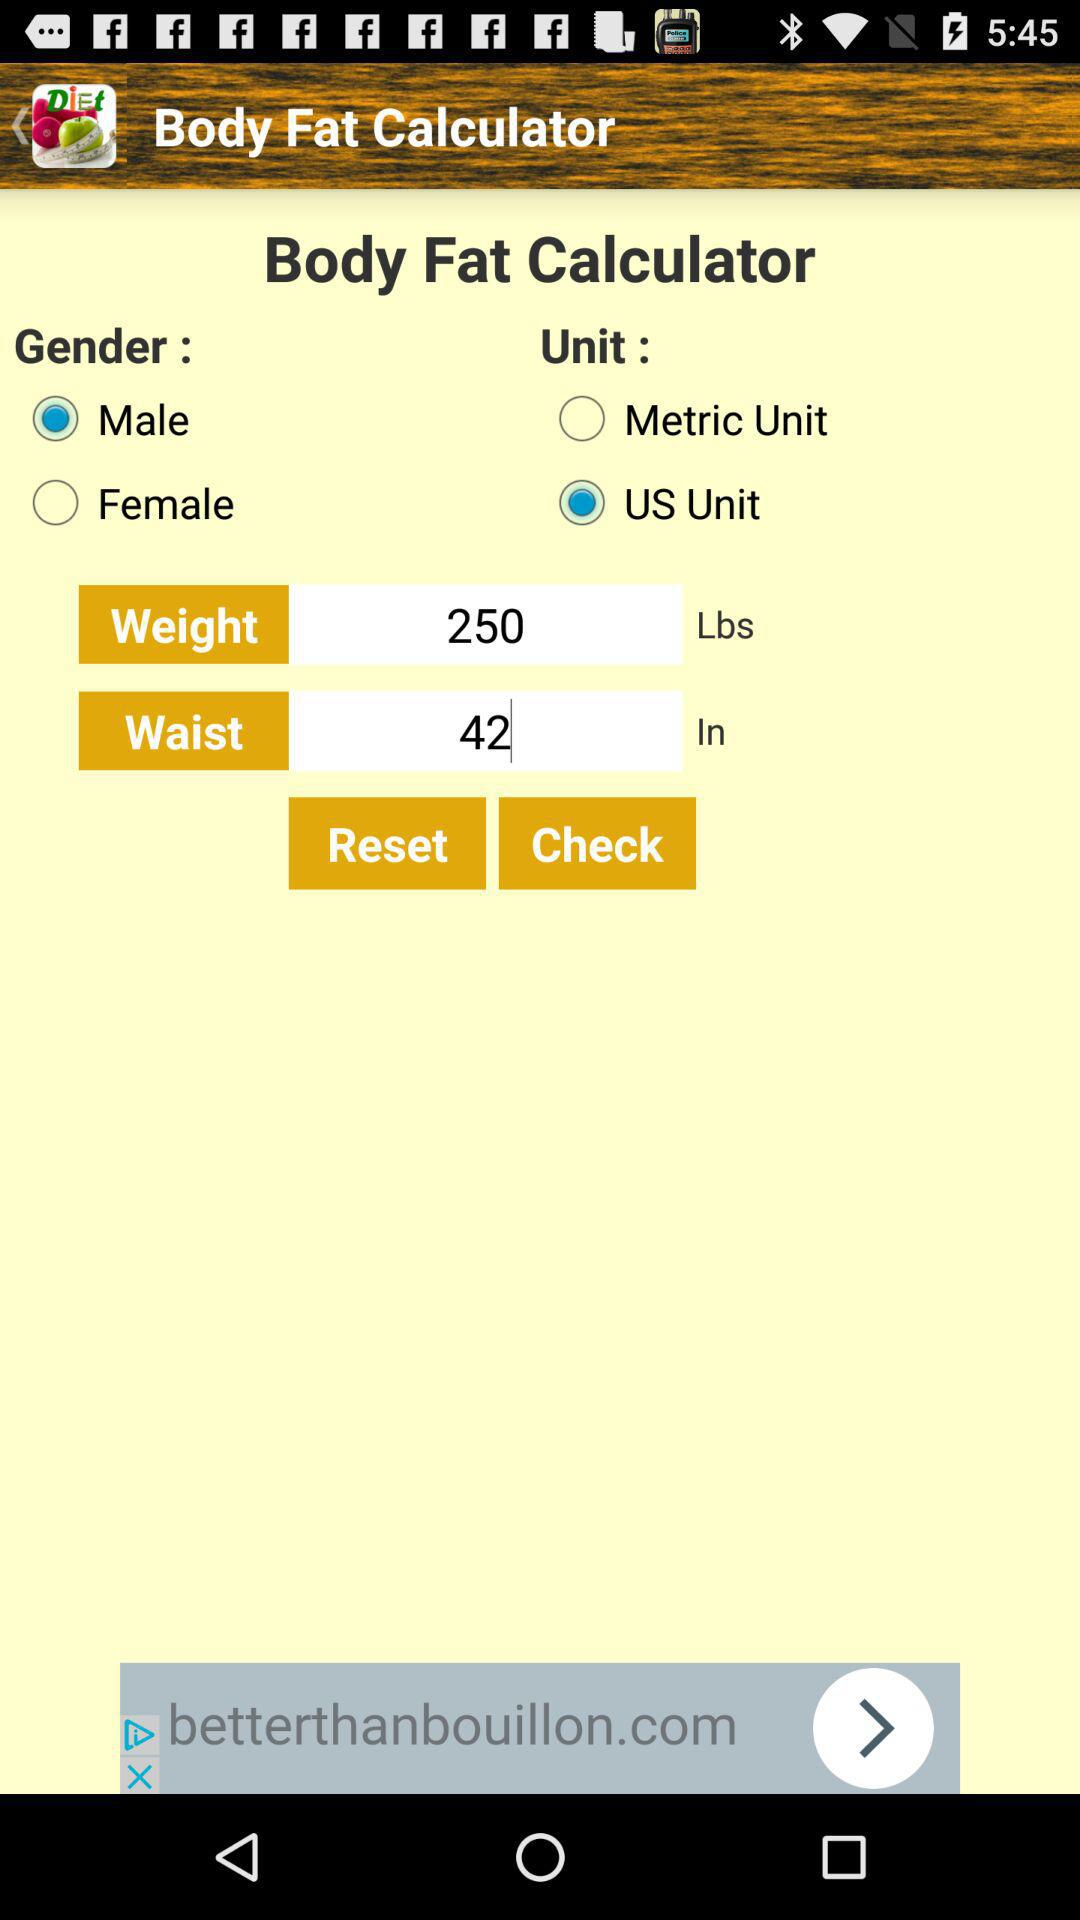What is the application name? The application name is "Body Fat Calculator". 